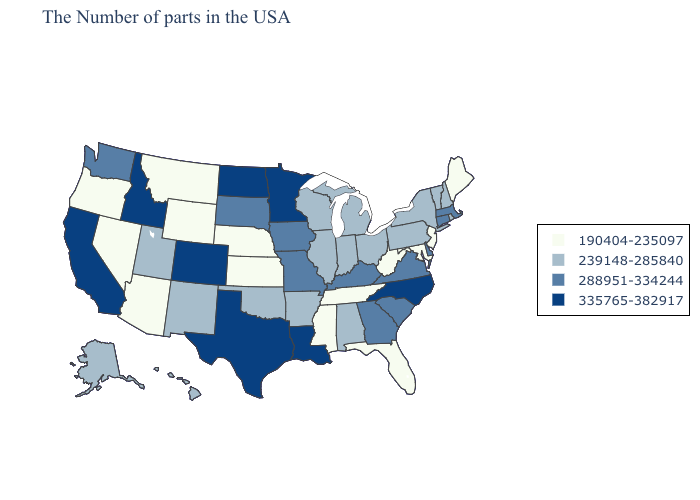Does New Hampshire have the lowest value in the Northeast?
Give a very brief answer. No. What is the highest value in the Northeast ?
Concise answer only. 288951-334244. Does the first symbol in the legend represent the smallest category?
Answer briefly. Yes. Does Wisconsin have the same value as Delaware?
Short answer required. No. Which states have the lowest value in the South?
Keep it brief. Maryland, West Virginia, Florida, Tennessee, Mississippi. Name the states that have a value in the range 190404-235097?
Keep it brief. Maine, New Jersey, Maryland, West Virginia, Florida, Tennessee, Mississippi, Kansas, Nebraska, Wyoming, Montana, Arizona, Nevada, Oregon. What is the highest value in the USA?
Write a very short answer. 335765-382917. Name the states that have a value in the range 239148-285840?
Short answer required. Rhode Island, New Hampshire, Vermont, New York, Pennsylvania, Ohio, Michigan, Indiana, Alabama, Wisconsin, Illinois, Arkansas, Oklahoma, New Mexico, Utah, Alaska, Hawaii. Among the states that border Delaware , which have the lowest value?
Keep it brief. New Jersey, Maryland. Name the states that have a value in the range 239148-285840?
Quick response, please. Rhode Island, New Hampshire, Vermont, New York, Pennsylvania, Ohio, Michigan, Indiana, Alabama, Wisconsin, Illinois, Arkansas, Oklahoma, New Mexico, Utah, Alaska, Hawaii. Does Nebraska have the same value as Nevada?
Keep it brief. Yes. Among the states that border Arkansas , which have the highest value?
Quick response, please. Louisiana, Texas. What is the highest value in states that border Florida?
Quick response, please. 288951-334244. What is the lowest value in the South?
Answer briefly. 190404-235097. What is the lowest value in the USA?
Give a very brief answer. 190404-235097. 